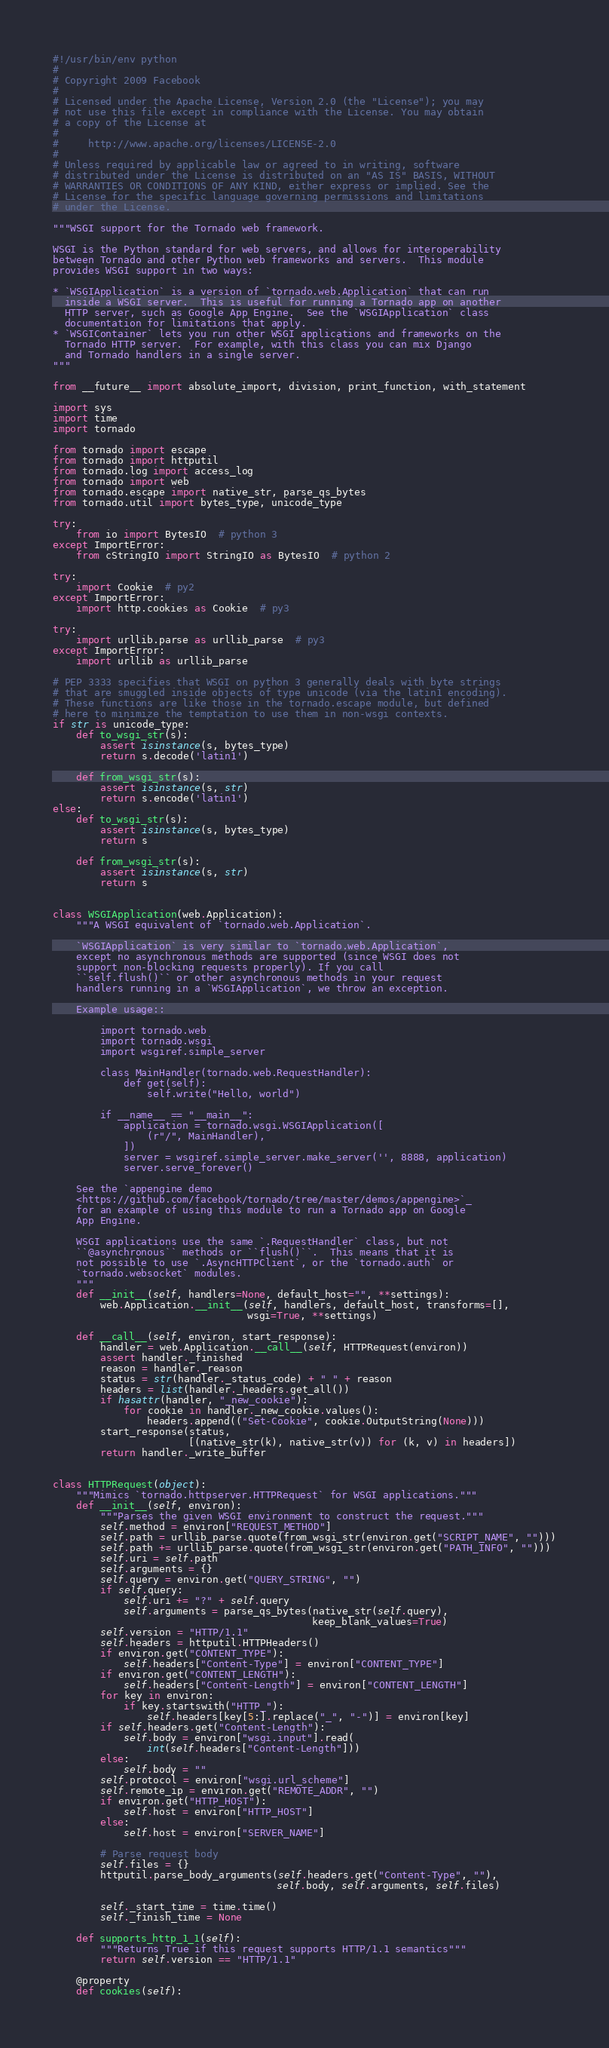Convert code to text. <code><loc_0><loc_0><loc_500><loc_500><_Python_>#!/usr/bin/env python
#
# Copyright 2009 Facebook
#
# Licensed under the Apache License, Version 2.0 (the "License"); you may
# not use this file except in compliance with the License. You may obtain
# a copy of the License at
#
#     http://www.apache.org/licenses/LICENSE-2.0
#
# Unless required by applicable law or agreed to in writing, software
# distributed under the License is distributed on an "AS IS" BASIS, WITHOUT
# WARRANTIES OR CONDITIONS OF ANY KIND, either express or implied. See the
# License for the specific language governing permissions and limitations
# under the License.

"""WSGI support for the Tornado web framework.

WSGI is the Python standard for web servers, and allows for interoperability
between Tornado and other Python web frameworks and servers.  This module
provides WSGI support in two ways:

* `WSGIApplication` is a version of `tornado.web.Application` that can run
  inside a WSGI server.  This is useful for running a Tornado app on another
  HTTP server, such as Google App Engine.  See the `WSGIApplication` class
  documentation for limitations that apply.
* `WSGIContainer` lets you run other WSGI applications and frameworks on the
  Tornado HTTP server.  For example, with this class you can mix Django
  and Tornado handlers in a single server.
"""

from __future__ import absolute_import, division, print_function, with_statement

import sys
import time
import tornado

from tornado import escape
from tornado import httputil
from tornado.log import access_log
from tornado import web
from tornado.escape import native_str, parse_qs_bytes
from tornado.util import bytes_type, unicode_type

try:
    from io import BytesIO  # python 3
except ImportError:
    from cStringIO import StringIO as BytesIO  # python 2

try:
    import Cookie  # py2
except ImportError:
    import http.cookies as Cookie  # py3

try:
    import urllib.parse as urllib_parse  # py3
except ImportError:
    import urllib as urllib_parse

# PEP 3333 specifies that WSGI on python 3 generally deals with byte strings
# that are smuggled inside objects of type unicode (via the latin1 encoding).
# These functions are like those in the tornado.escape module, but defined
# here to minimize the temptation to use them in non-wsgi contexts.
if str is unicode_type:
    def to_wsgi_str(s):
        assert isinstance(s, bytes_type)
        return s.decode('latin1')

    def from_wsgi_str(s):
        assert isinstance(s, str)
        return s.encode('latin1')
else:
    def to_wsgi_str(s):
        assert isinstance(s, bytes_type)
        return s

    def from_wsgi_str(s):
        assert isinstance(s, str)
        return s


class WSGIApplication(web.Application):
    """A WSGI equivalent of `tornado.web.Application`.

    `WSGIApplication` is very similar to `tornado.web.Application`,
    except no asynchronous methods are supported (since WSGI does not
    support non-blocking requests properly). If you call
    ``self.flush()`` or other asynchronous methods in your request
    handlers running in a `WSGIApplication`, we throw an exception.

    Example usage::

        import tornado.web
        import tornado.wsgi
        import wsgiref.simple_server

        class MainHandler(tornado.web.RequestHandler):
            def get(self):
                self.write("Hello, world")

        if __name__ == "__main__":
            application = tornado.wsgi.WSGIApplication([
                (r"/", MainHandler),
            ])
            server = wsgiref.simple_server.make_server('', 8888, application)
            server.serve_forever()

    See the `appengine demo
    <https://github.com/facebook/tornado/tree/master/demos/appengine>`_
    for an example of using this module to run a Tornado app on Google
    App Engine.

    WSGI applications use the same `.RequestHandler` class, but not
    ``@asynchronous`` methods or ``flush()``.  This means that it is
    not possible to use `.AsyncHTTPClient`, or the `tornado.auth` or
    `tornado.websocket` modules.
    """
    def __init__(self, handlers=None, default_host="", **settings):
        web.Application.__init__(self, handlers, default_host, transforms=[],
                                 wsgi=True, **settings)

    def __call__(self, environ, start_response):
        handler = web.Application.__call__(self, HTTPRequest(environ))
        assert handler._finished
        reason = handler._reason
        status = str(handler._status_code) + " " + reason
        headers = list(handler._headers.get_all())
        if hasattr(handler, "_new_cookie"):
            for cookie in handler._new_cookie.values():
                headers.append(("Set-Cookie", cookie.OutputString(None)))
        start_response(status,
                       [(native_str(k), native_str(v)) for (k, v) in headers])
        return handler._write_buffer


class HTTPRequest(object):
    """Mimics `tornado.httpserver.HTTPRequest` for WSGI applications."""
    def __init__(self, environ):
        """Parses the given WSGI environment to construct the request."""
        self.method = environ["REQUEST_METHOD"]
        self.path = urllib_parse.quote(from_wsgi_str(environ.get("SCRIPT_NAME", "")))
        self.path += urllib_parse.quote(from_wsgi_str(environ.get("PATH_INFO", "")))
        self.uri = self.path
        self.arguments = {}
        self.query = environ.get("QUERY_STRING", "")
        if self.query:
            self.uri += "?" + self.query
            self.arguments = parse_qs_bytes(native_str(self.query),
                                            keep_blank_values=True)
        self.version = "HTTP/1.1"
        self.headers = httputil.HTTPHeaders()
        if environ.get("CONTENT_TYPE"):
            self.headers["Content-Type"] = environ["CONTENT_TYPE"]
        if environ.get("CONTENT_LENGTH"):
            self.headers["Content-Length"] = environ["CONTENT_LENGTH"]
        for key in environ:
            if key.startswith("HTTP_"):
                self.headers[key[5:].replace("_", "-")] = environ[key]
        if self.headers.get("Content-Length"):
            self.body = environ["wsgi.input"].read(
                int(self.headers["Content-Length"]))
        else:
            self.body = ""
        self.protocol = environ["wsgi.url_scheme"]
        self.remote_ip = environ.get("REMOTE_ADDR", "")
        if environ.get("HTTP_HOST"):
            self.host = environ["HTTP_HOST"]
        else:
            self.host = environ["SERVER_NAME"]

        # Parse request body
        self.files = {}
        httputil.parse_body_arguments(self.headers.get("Content-Type", ""),
                                      self.body, self.arguments, self.files)

        self._start_time = time.time()
        self._finish_time = None

    def supports_http_1_1(self):
        """Returns True if this request supports HTTP/1.1 semantics"""
        return self.version == "HTTP/1.1"

    @property
    def cookies(self):</code> 